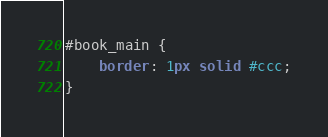Convert code to text. <code><loc_0><loc_0><loc_500><loc_500><_CSS_>#book_main {
	border: 1px solid #ccc;
}
</code> 